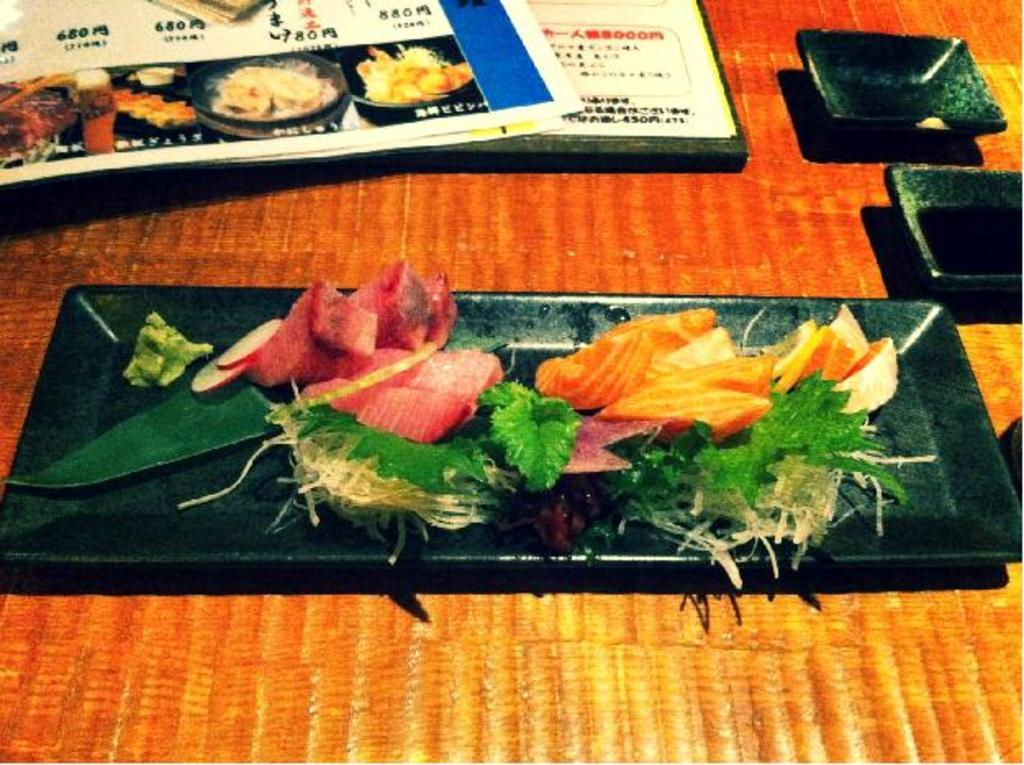What is placed on the table in the image? There is a pamphlet, cups, and a tray on the table. What is on the tray? There are pieces of meat, carrots, and other vegetables on the tray. What might be used for holding or serving food in the image? The tray and cups can be used for holding or serving food. What type of art can be seen on the wall in the image? There is no art or wall visible in the image; it only shows a table with various items on it. 